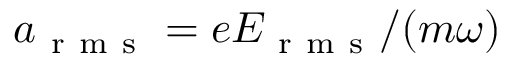Convert formula to latex. <formula><loc_0><loc_0><loc_500><loc_500>a _ { r m s } = e E _ { r m s } / ( m \omega )</formula> 